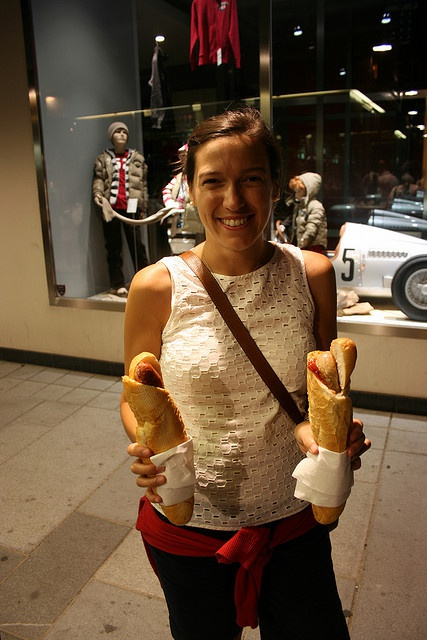Describe the objects in this image and their specific colors. I can see people in black, maroon, brown, and tan tones, hot dog in black, brown, maroon, and gray tones, people in black, maroon, tan, and gray tones, car in black, white, darkgray, and gray tones, and hot dog in black, olive, maroon, and orange tones in this image. 